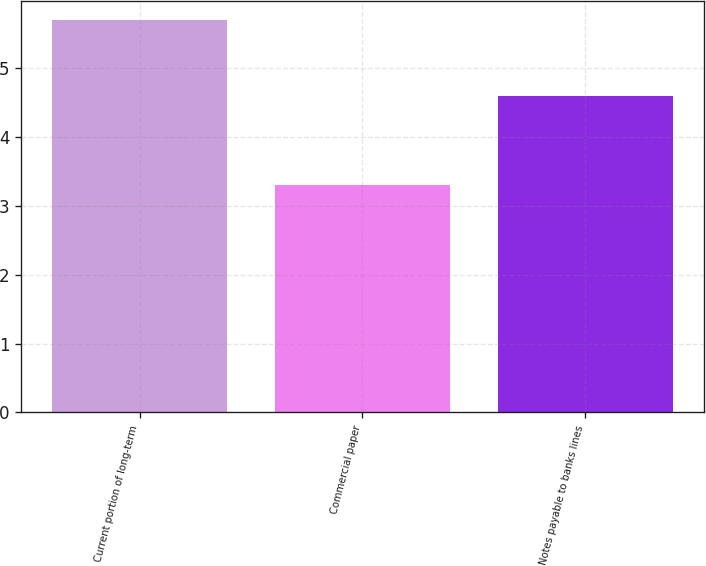Convert chart to OTSL. <chart><loc_0><loc_0><loc_500><loc_500><bar_chart><fcel>Current portion of long-term<fcel>Commercial paper<fcel>Notes payable to banks lines<nl><fcel>5.7<fcel>3.3<fcel>4.6<nl></chart> 